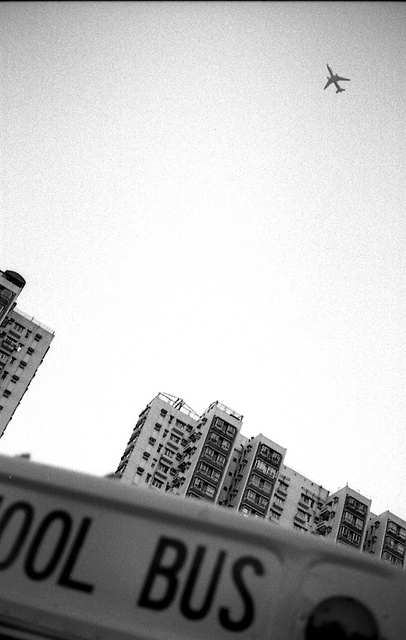Identify the text displayed in this image. OOL BUS 